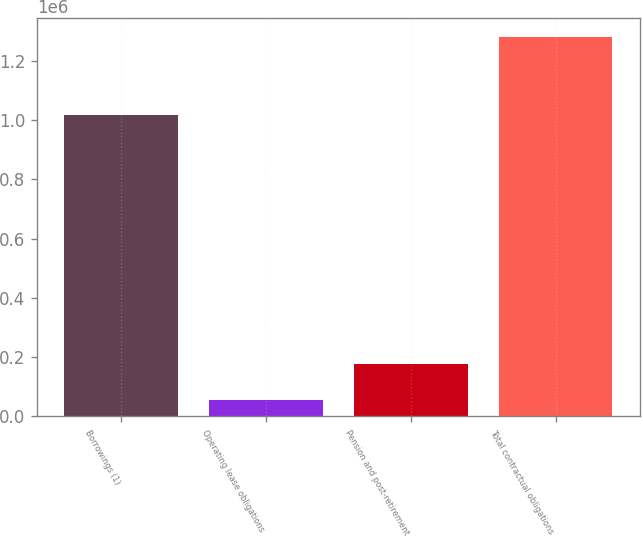Convert chart to OTSL. <chart><loc_0><loc_0><loc_500><loc_500><bar_chart><fcel>Borrowings (1)<fcel>Operating lease obligations<fcel>Pension and post-retirement<fcel>Total contractual obligations<nl><fcel>1.01823e+06<fcel>54406<fcel>177182<fcel>1.28217e+06<nl></chart> 